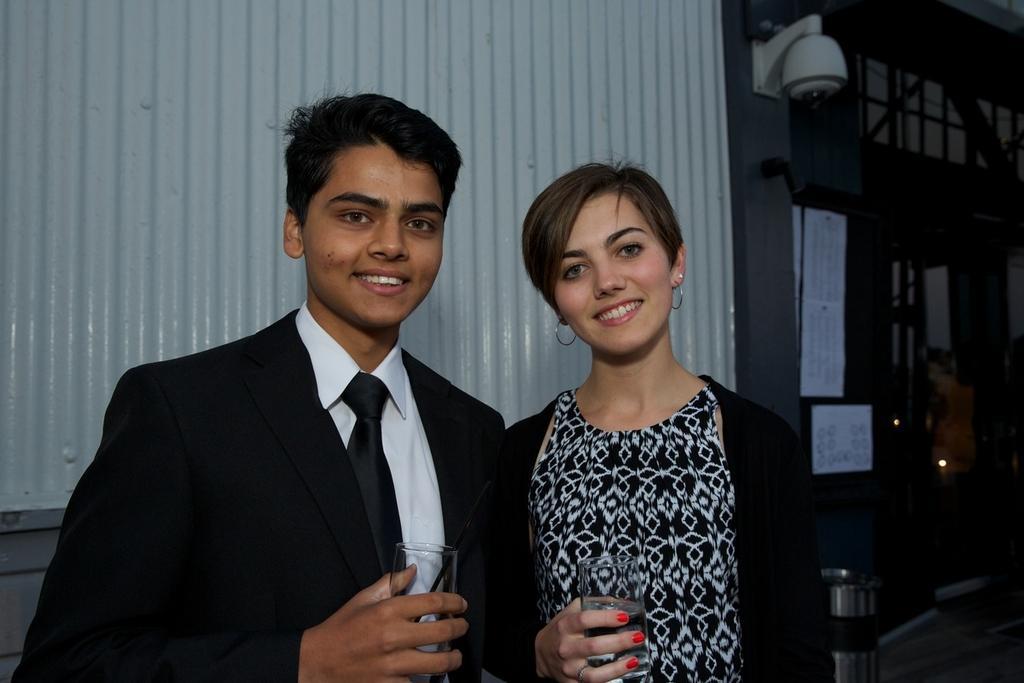How would you summarize this image in a sentence or two? In this image in the front there are persons standing and smiling and holding glass in their hands. In the background there is a wall and on the wall there are objects, which are white in colour and there is a light hanging and there is a door and window and there is a bin. 